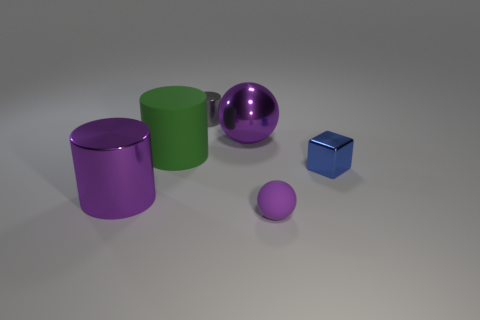The big object that is both behind the blue block and on the left side of the small gray thing is what color?
Offer a terse response. Green. Is the size of the purple sphere in front of the blue object the same as the green cylinder?
Keep it short and to the point. No. Are there more tiny metallic objects that are behind the small blue block than large green shiny cylinders?
Your answer should be very brief. Yes. Is the shape of the small gray thing the same as the green rubber object?
Your response must be concise. Yes. The purple metal ball is what size?
Your response must be concise. Large. Are there more small gray cylinders that are on the right side of the small purple rubber thing than blue cubes that are on the left side of the gray cylinder?
Your answer should be very brief. No. There is a green rubber cylinder; are there any big purple things behind it?
Offer a terse response. Yes. Is there a green matte cylinder of the same size as the purple metal sphere?
Give a very brief answer. Yes. There is a small cylinder that is the same material as the tiny blue object; what color is it?
Ensure brevity in your answer.  Gray. What is the material of the small cube?
Your response must be concise. Metal. 